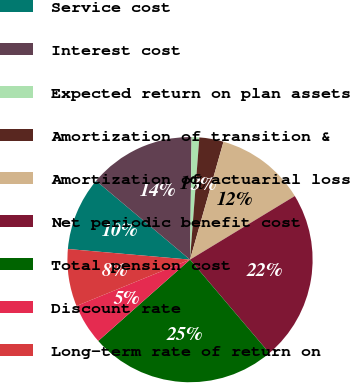Convert chart to OTSL. <chart><loc_0><loc_0><loc_500><loc_500><pie_chart><fcel>Service cost<fcel>Interest cost<fcel>Expected return on plan assets<fcel>Amortization of transition &<fcel>Amortization of actuarial loss<fcel>Net periodic benefit cost<fcel>Total pension cost<fcel>Discount rate<fcel>Long-term rate of return on<nl><fcel>9.73%<fcel>14.09%<fcel>1.01%<fcel>3.19%<fcel>11.91%<fcel>22.48%<fcel>24.66%<fcel>5.37%<fcel>7.55%<nl></chart> 